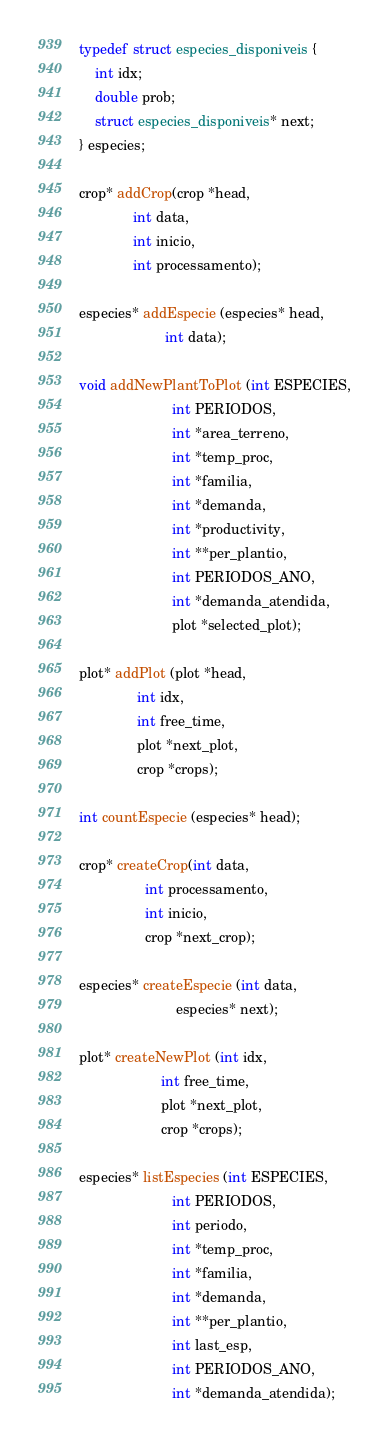<code> <loc_0><loc_0><loc_500><loc_500><_C_>typedef struct especies_disponiveis {
    int idx;
    double prob;
    struct especies_disponiveis* next;
} especies;

crop* addCrop(crop *head,
              int data,
              int inicio,
              int processamento);

especies* addEspecie (especies* head,
                      int data);

void addNewPlantToPlot (int ESPECIES,
                        int PERIODOS,
                        int *area_terreno,
                        int *temp_proc,
                        int *familia,
                        int *demanda,
                        int *productivity,
                        int **per_plantio,
                        int PERIODOS_ANO,
                        int *demanda_atendida,
                        plot *selected_plot);

plot* addPlot (plot *head,
               int idx,
               int free_time,
               plot *next_plot,
               crop *crops);

int countEspecie (especies* head);

crop* createCrop(int data,
                 int processamento,
                 int inicio,
                 crop *next_crop);

especies* createEspecie (int data,
                         especies* next);

plot* createNewPlot (int idx,
                     int free_time,
                     plot *next_plot,
                     crop *crops);

especies* listEspecies (int ESPECIES,
                        int PERIODOS,
                        int periodo,
                        int *temp_proc,
                        int *familia,
                        int *demanda,
                        int **per_plantio,
                        int last_esp,
                        int PERIODOS_ANO,
                        int *demanda_atendida);
</code> 